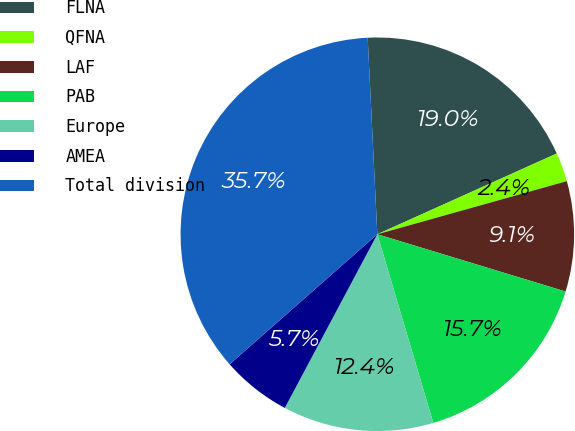Convert chart to OTSL. <chart><loc_0><loc_0><loc_500><loc_500><pie_chart><fcel>FLNA<fcel>QFNA<fcel>LAF<fcel>PAB<fcel>Europe<fcel>AMEA<fcel>Total division<nl><fcel>19.05%<fcel>2.38%<fcel>9.05%<fcel>15.71%<fcel>12.38%<fcel>5.72%<fcel>35.71%<nl></chart> 